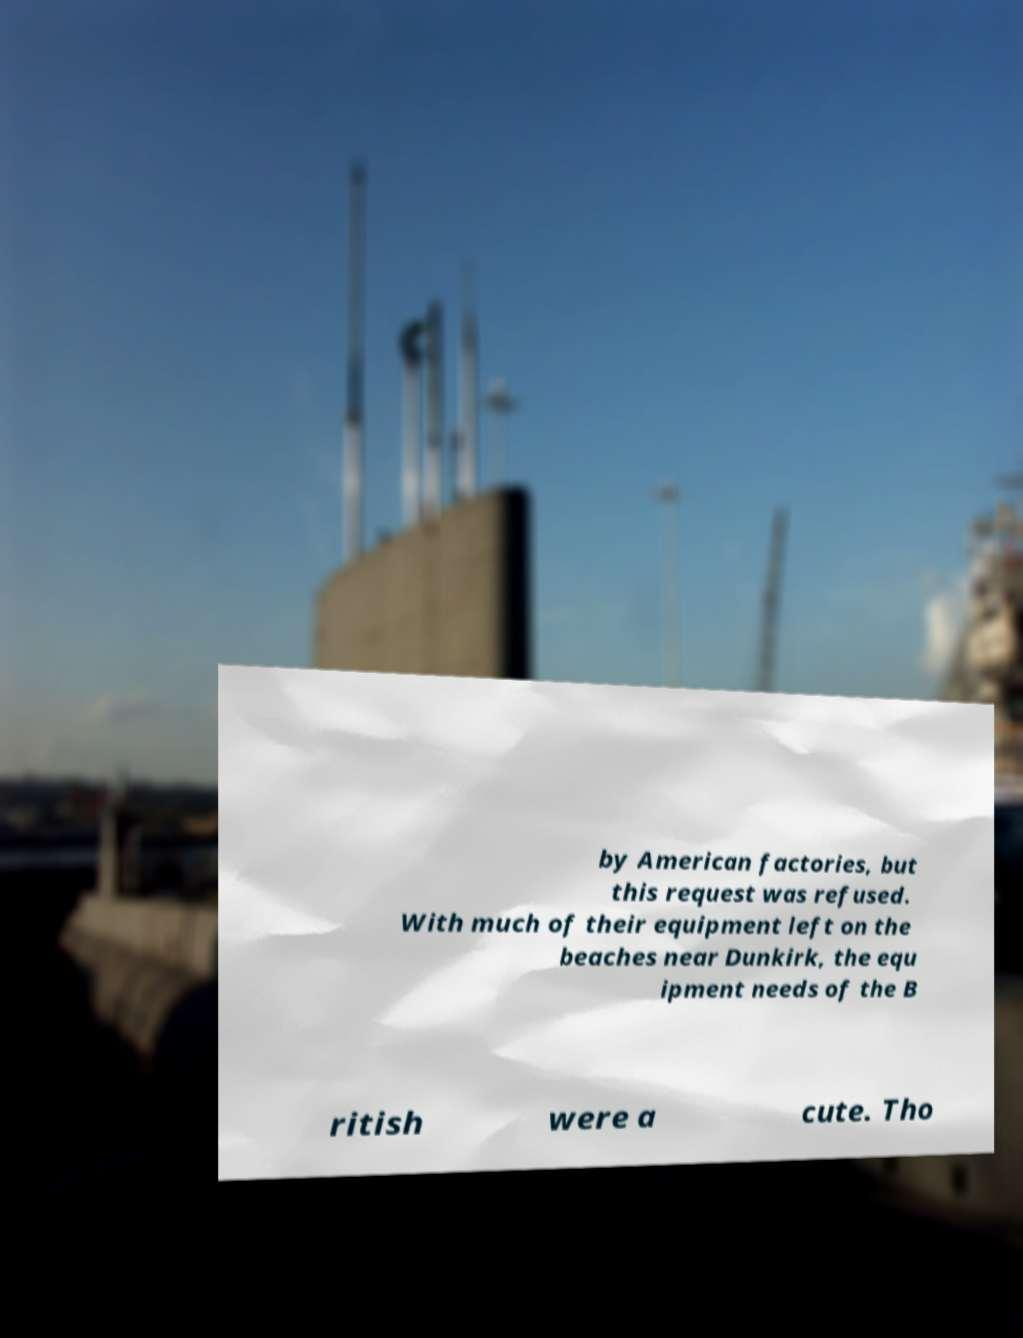Can you read and provide the text displayed in the image?This photo seems to have some interesting text. Can you extract and type it out for me? by American factories, but this request was refused. With much of their equipment left on the beaches near Dunkirk, the equ ipment needs of the B ritish were a cute. Tho 